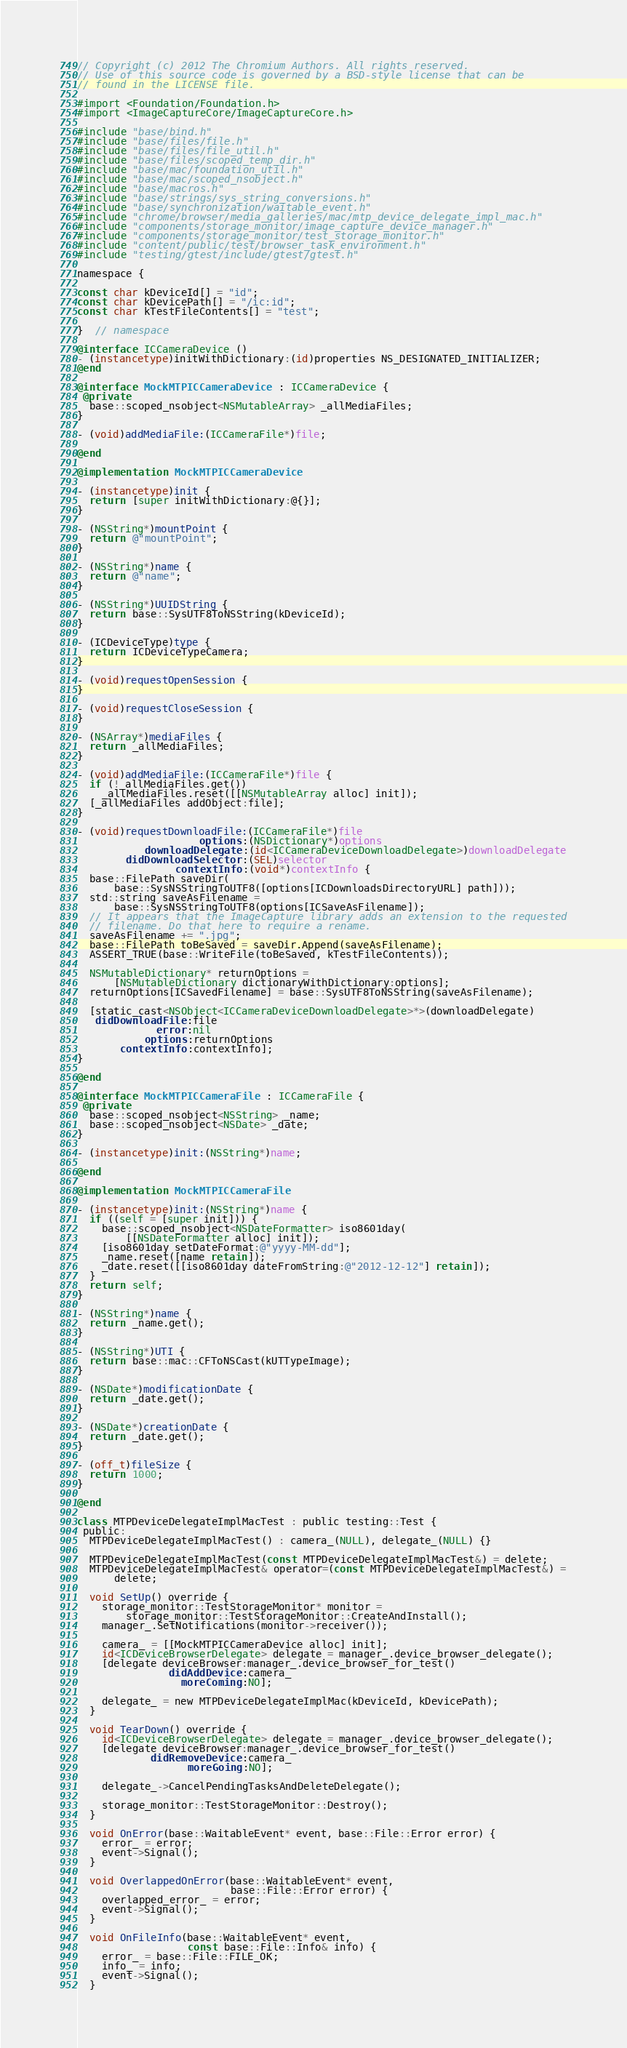Convert code to text. <code><loc_0><loc_0><loc_500><loc_500><_ObjectiveC_>// Copyright (c) 2012 The Chromium Authors. All rights reserved.
// Use of this source code is governed by a BSD-style license that can be
// found in the LICENSE file.

#import <Foundation/Foundation.h>
#import <ImageCaptureCore/ImageCaptureCore.h>

#include "base/bind.h"
#include "base/files/file.h"
#include "base/files/file_util.h"
#include "base/files/scoped_temp_dir.h"
#include "base/mac/foundation_util.h"
#include "base/mac/scoped_nsobject.h"
#include "base/macros.h"
#include "base/strings/sys_string_conversions.h"
#include "base/synchronization/waitable_event.h"
#include "chrome/browser/media_galleries/mac/mtp_device_delegate_impl_mac.h"
#include "components/storage_monitor/image_capture_device_manager.h"
#include "components/storage_monitor/test_storage_monitor.h"
#include "content/public/test/browser_task_environment.h"
#include "testing/gtest/include/gtest/gtest.h"

namespace {

const char kDeviceId[] = "id";
const char kDevicePath[] = "/ic:id";
const char kTestFileContents[] = "test";

}  // namespace

@interface ICCameraDevice ()
- (instancetype)initWithDictionary:(id)properties NS_DESIGNATED_INITIALIZER;
@end

@interface MockMTPICCameraDevice : ICCameraDevice {
 @private
  base::scoped_nsobject<NSMutableArray> _allMediaFiles;
}

- (void)addMediaFile:(ICCameraFile*)file;

@end

@implementation MockMTPICCameraDevice

- (instancetype)init {
  return [super initWithDictionary:@{}];
}

- (NSString*)mountPoint {
  return @"mountPoint";
}

- (NSString*)name {
  return @"name";
}

- (NSString*)UUIDString {
  return base::SysUTF8ToNSString(kDeviceId);
}

- (ICDeviceType)type {
  return ICDeviceTypeCamera;
}

- (void)requestOpenSession {
}

- (void)requestCloseSession {
}

- (NSArray*)mediaFiles {
  return _allMediaFiles;
}

- (void)addMediaFile:(ICCameraFile*)file {
  if (!_allMediaFiles.get())
    _allMediaFiles.reset([[NSMutableArray alloc] init]);
  [_allMediaFiles addObject:file];
}

- (void)requestDownloadFile:(ICCameraFile*)file
                    options:(NSDictionary*)options
           downloadDelegate:(id<ICCameraDeviceDownloadDelegate>)downloadDelegate
        didDownloadSelector:(SEL)selector
                contextInfo:(void*)contextInfo {
  base::FilePath saveDir(
      base::SysNSStringToUTF8([options[ICDownloadsDirectoryURL] path]));
  std::string saveAsFilename =
      base::SysNSStringToUTF8(options[ICSaveAsFilename]);
  // It appears that the ImageCapture library adds an extension to the requested
  // filename. Do that here to require a rename.
  saveAsFilename += ".jpg";
  base::FilePath toBeSaved = saveDir.Append(saveAsFilename);
  ASSERT_TRUE(base::WriteFile(toBeSaved, kTestFileContents));

  NSMutableDictionary* returnOptions =
      [NSMutableDictionary dictionaryWithDictionary:options];
  returnOptions[ICSavedFilename] = base::SysUTF8ToNSString(saveAsFilename);

  [static_cast<NSObject<ICCameraDeviceDownloadDelegate>*>(downloadDelegate)
   didDownloadFile:file
             error:nil
           options:returnOptions
       contextInfo:contextInfo];
}

@end

@interface MockMTPICCameraFile : ICCameraFile {
 @private
  base::scoped_nsobject<NSString> _name;
  base::scoped_nsobject<NSDate> _date;
}

- (instancetype)init:(NSString*)name;

@end

@implementation MockMTPICCameraFile

- (instancetype)init:(NSString*)name {
  if ((self = [super init])) {
    base::scoped_nsobject<NSDateFormatter> iso8601day(
        [[NSDateFormatter alloc] init]);
    [iso8601day setDateFormat:@"yyyy-MM-dd"];
    _name.reset([name retain]);
    _date.reset([[iso8601day dateFromString:@"2012-12-12"] retain]);
  }
  return self;
}

- (NSString*)name {
  return _name.get();
}

- (NSString*)UTI {
  return base::mac::CFToNSCast(kUTTypeImage);
}

- (NSDate*)modificationDate {
  return _date.get();
}

- (NSDate*)creationDate {
  return _date.get();
}

- (off_t)fileSize {
  return 1000;
}

@end

class MTPDeviceDelegateImplMacTest : public testing::Test {
 public:
  MTPDeviceDelegateImplMacTest() : camera_(NULL), delegate_(NULL) {}

  MTPDeviceDelegateImplMacTest(const MTPDeviceDelegateImplMacTest&) = delete;
  MTPDeviceDelegateImplMacTest& operator=(const MTPDeviceDelegateImplMacTest&) =
      delete;

  void SetUp() override {
    storage_monitor::TestStorageMonitor* monitor =
        storage_monitor::TestStorageMonitor::CreateAndInstall();
    manager_.SetNotifications(monitor->receiver());

    camera_ = [[MockMTPICCameraDevice alloc] init];
    id<ICDeviceBrowserDelegate> delegate = manager_.device_browser_delegate();
    [delegate deviceBrowser:manager_.device_browser_for_test()
               didAddDevice:camera_
                 moreComing:NO];

    delegate_ = new MTPDeviceDelegateImplMac(kDeviceId, kDevicePath);
  }

  void TearDown() override {
    id<ICDeviceBrowserDelegate> delegate = manager_.device_browser_delegate();
    [delegate deviceBrowser:manager_.device_browser_for_test()
            didRemoveDevice:camera_
                  moreGoing:NO];

    delegate_->CancelPendingTasksAndDeleteDelegate();

    storage_monitor::TestStorageMonitor::Destroy();
  }

  void OnError(base::WaitableEvent* event, base::File::Error error) {
    error_ = error;
    event->Signal();
  }

  void OverlappedOnError(base::WaitableEvent* event,
                         base::File::Error error) {
    overlapped_error_ = error;
    event->Signal();
  }

  void OnFileInfo(base::WaitableEvent* event,
                  const base::File::Info& info) {
    error_ = base::File::FILE_OK;
    info_ = info;
    event->Signal();
  }
</code> 